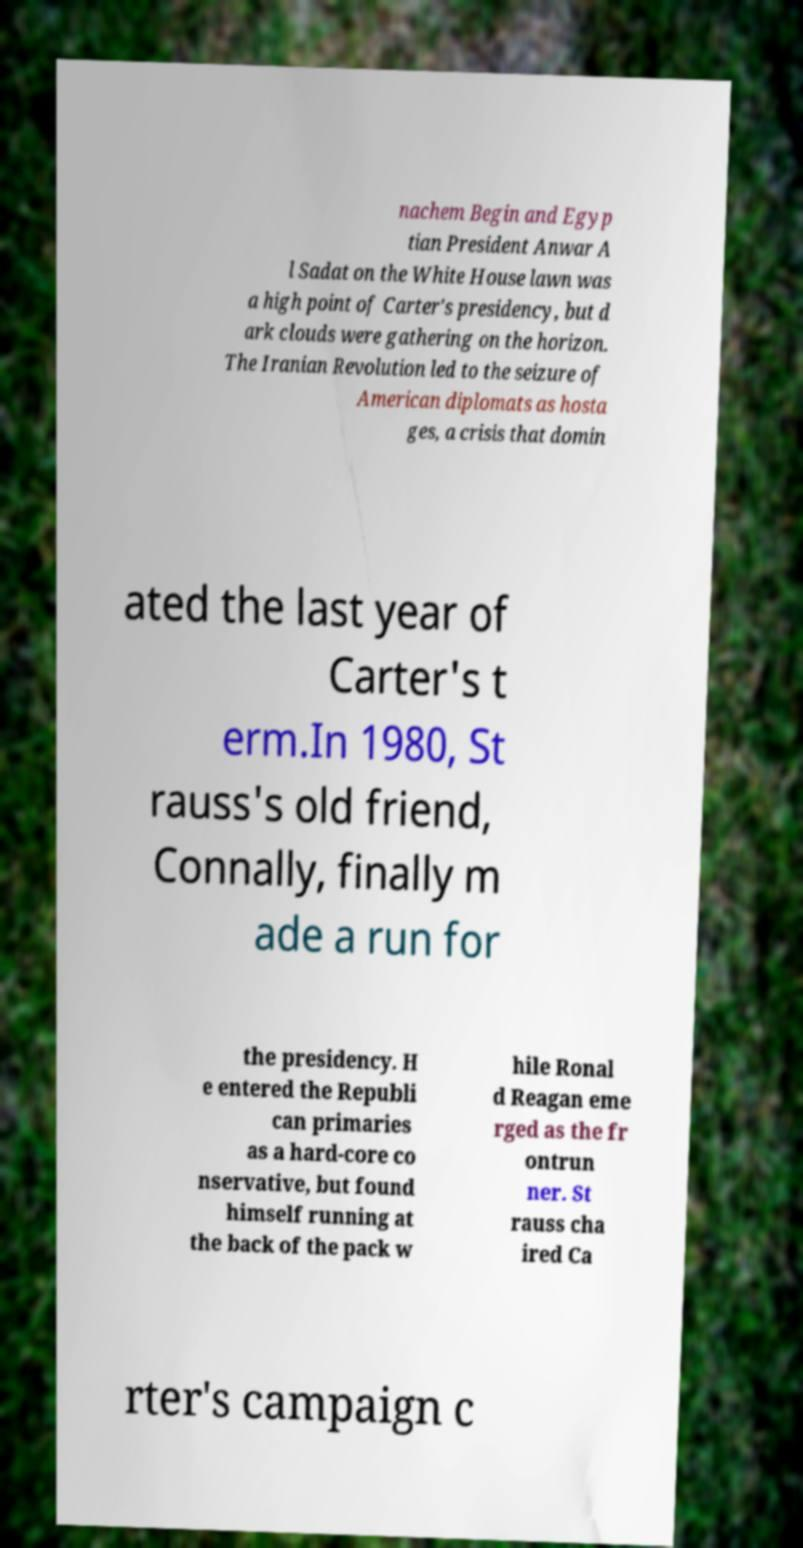Can you accurately transcribe the text from the provided image for me? nachem Begin and Egyp tian President Anwar A l Sadat on the White House lawn was a high point of Carter's presidency, but d ark clouds were gathering on the horizon. The Iranian Revolution led to the seizure of American diplomats as hosta ges, a crisis that domin ated the last year of Carter's t erm.In 1980, St rauss's old friend, Connally, finally m ade a run for the presidency. H e entered the Republi can primaries as a hard-core co nservative, but found himself running at the back of the pack w hile Ronal d Reagan eme rged as the fr ontrun ner. St rauss cha ired Ca rter's campaign c 